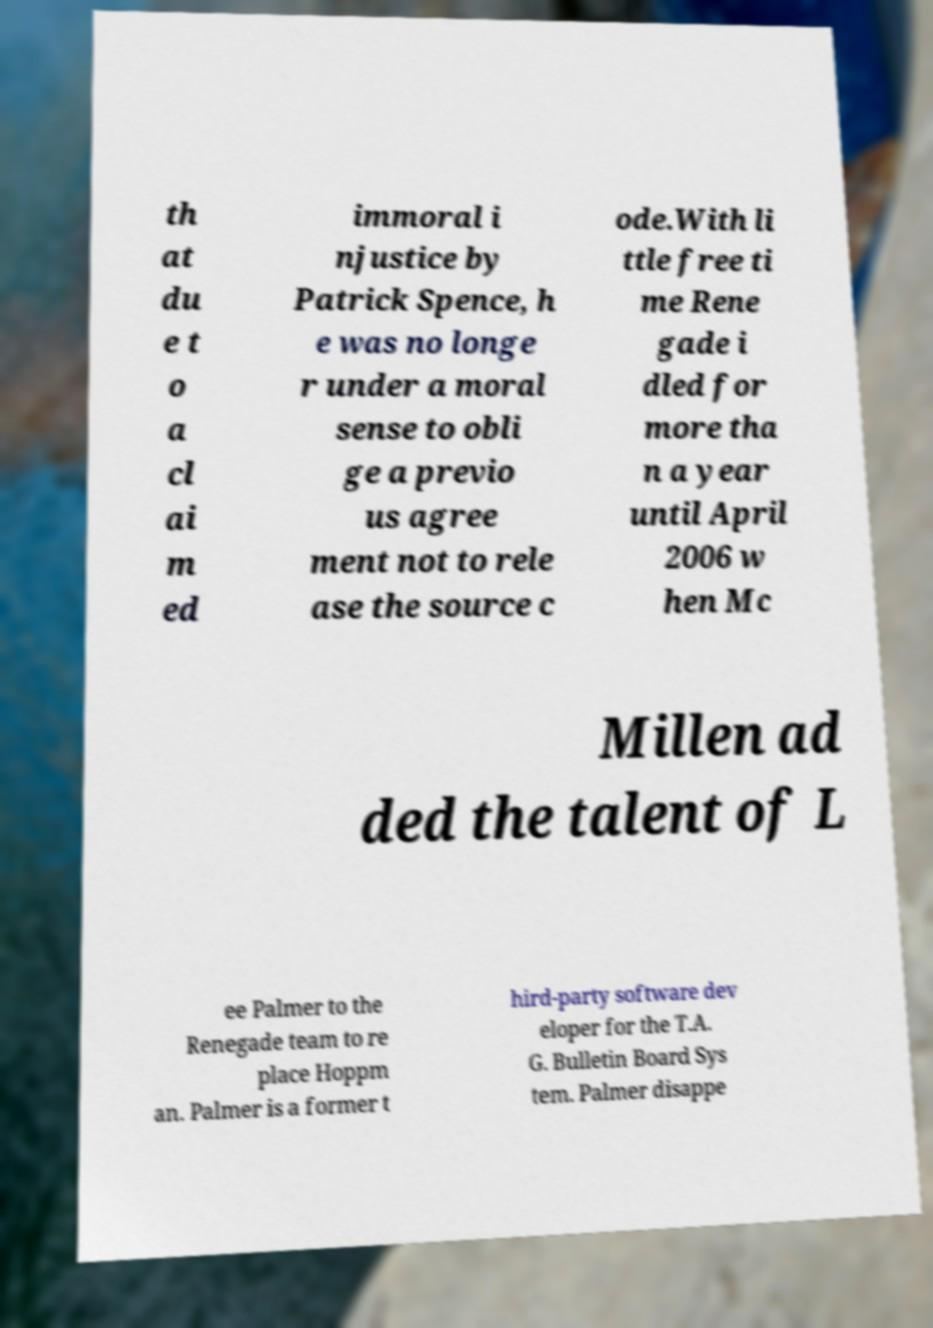There's text embedded in this image that I need extracted. Can you transcribe it verbatim? th at du e t o a cl ai m ed immoral i njustice by Patrick Spence, h e was no longe r under a moral sense to obli ge a previo us agree ment not to rele ase the source c ode.With li ttle free ti me Rene gade i dled for more tha n a year until April 2006 w hen Mc Millen ad ded the talent of L ee Palmer to the Renegade team to re place Hoppm an. Palmer is a former t hird-party software dev eloper for the T.A. G. Bulletin Board Sys tem. Palmer disappe 